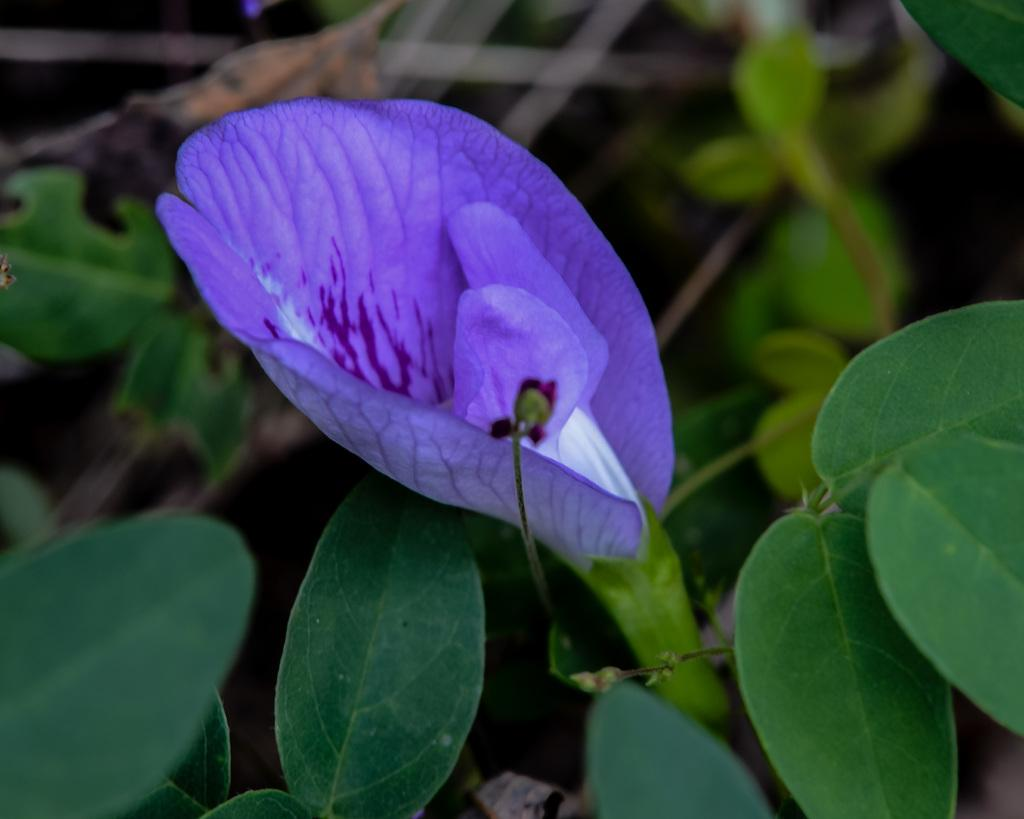What color is the flower in the image? The flower in the image is violet in color. What color are the leaves in the image? The leaves in the image are green in color. What can be seen in the background of the image? There are plants in the background of the image. How many cows are grazing in the background of the image? There are no cows present in the image; it features a violet flower, green leaves, and plants in the background. 